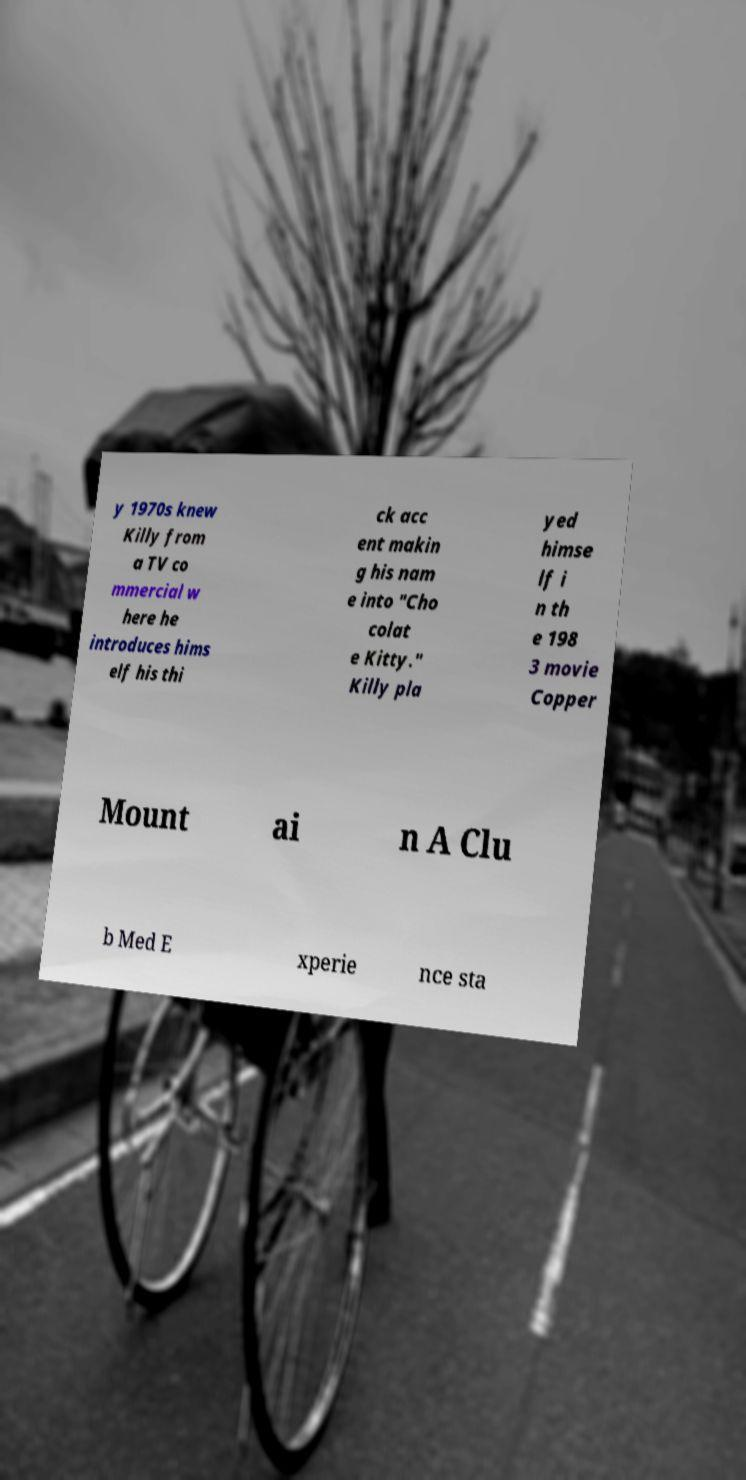Please read and relay the text visible in this image. What does it say? y 1970s knew Killy from a TV co mmercial w here he introduces hims elf his thi ck acc ent makin g his nam e into "Cho colat e Kitty." Killy pla yed himse lf i n th e 198 3 movie Copper Mount ai n A Clu b Med E xperie nce sta 